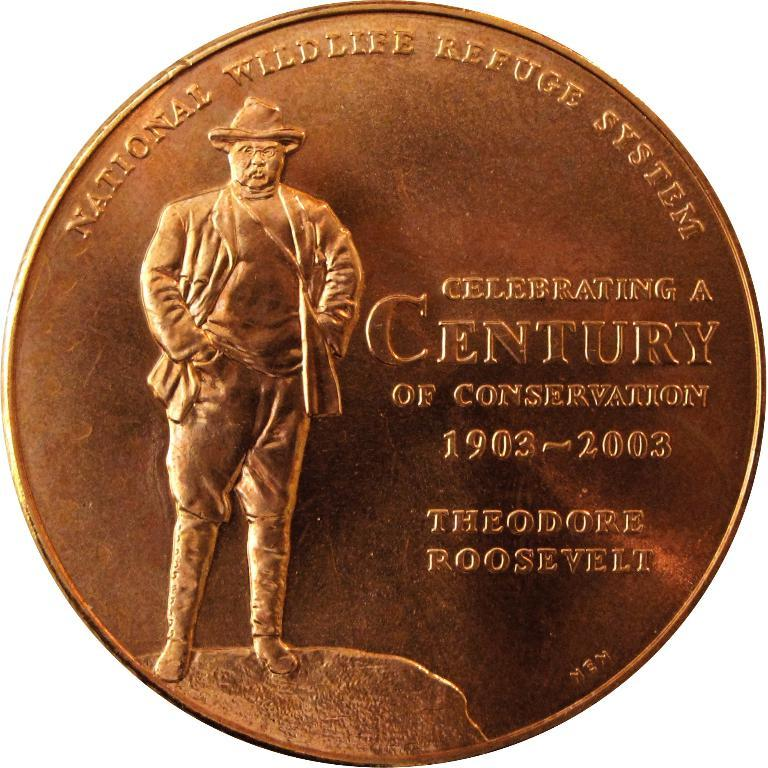<image>
Summarize the visual content of the image. a coin that says 'national wildlife refuge system' on the top of it 